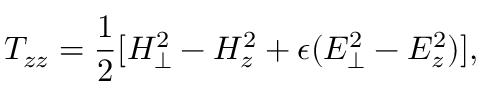Convert formula to latex. <formula><loc_0><loc_0><loc_500><loc_500>T _ { z z } = { \frac { 1 } { 2 } } [ H _ { \perp } ^ { 2 } - H _ { z } ^ { 2 } + \epsilon ( E _ { \perp } ^ { 2 } - E _ { z } ^ { 2 } ) ] ,</formula> 